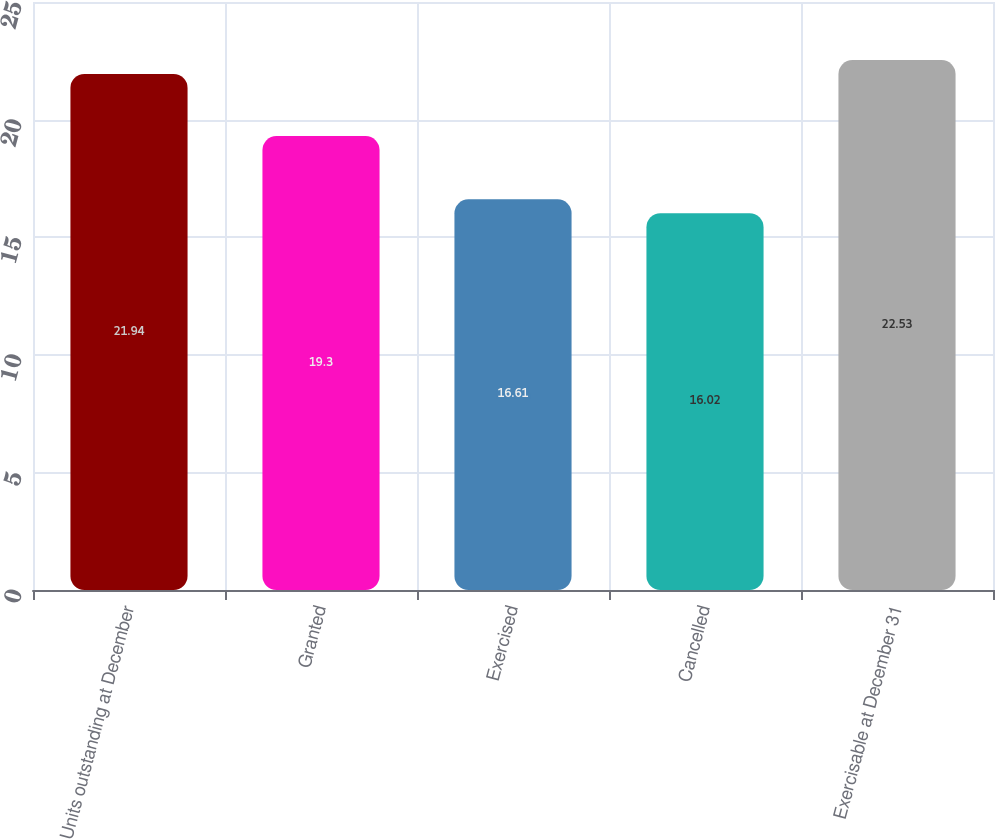<chart> <loc_0><loc_0><loc_500><loc_500><bar_chart><fcel>Units outstanding at December<fcel>Granted<fcel>Exercised<fcel>Cancelled<fcel>Exercisable at December 31<nl><fcel>21.94<fcel>19.3<fcel>16.61<fcel>16.02<fcel>22.53<nl></chart> 